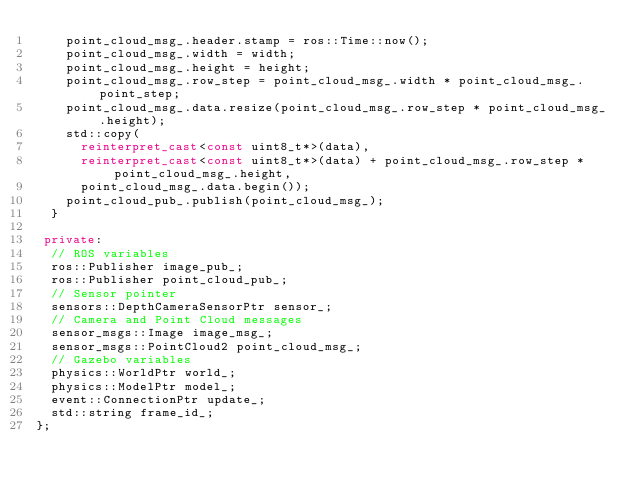<code> <loc_0><loc_0><loc_500><loc_500><_C++_>    point_cloud_msg_.header.stamp = ros::Time::now();
    point_cloud_msg_.width = width;
    point_cloud_msg_.height = height;
    point_cloud_msg_.row_step = point_cloud_msg_.width * point_cloud_msg_.point_step;
    point_cloud_msg_.data.resize(point_cloud_msg_.row_step * point_cloud_msg_.height);
    std::copy(
      reinterpret_cast<const uint8_t*>(data),
      reinterpret_cast<const uint8_t*>(data) + point_cloud_msg_.row_step * point_cloud_msg_.height,
      point_cloud_msg_.data.begin());
    point_cloud_pub_.publish(point_cloud_msg_);
  }

 private:
  // ROS variables
  ros::Publisher image_pub_;
  ros::Publisher point_cloud_pub_;
  // Sensor pointer
  sensors::DepthCameraSensorPtr sensor_;
  // Camera and Point Cloud messages
  sensor_msgs::Image image_msg_;
  sensor_msgs::PointCloud2 point_cloud_msg_;
  // Gazebo variables
  physics::WorldPtr world_;
  physics::ModelPtr model_;
  event::ConnectionPtr update_;
  std::string frame_id_;
};
</code> 